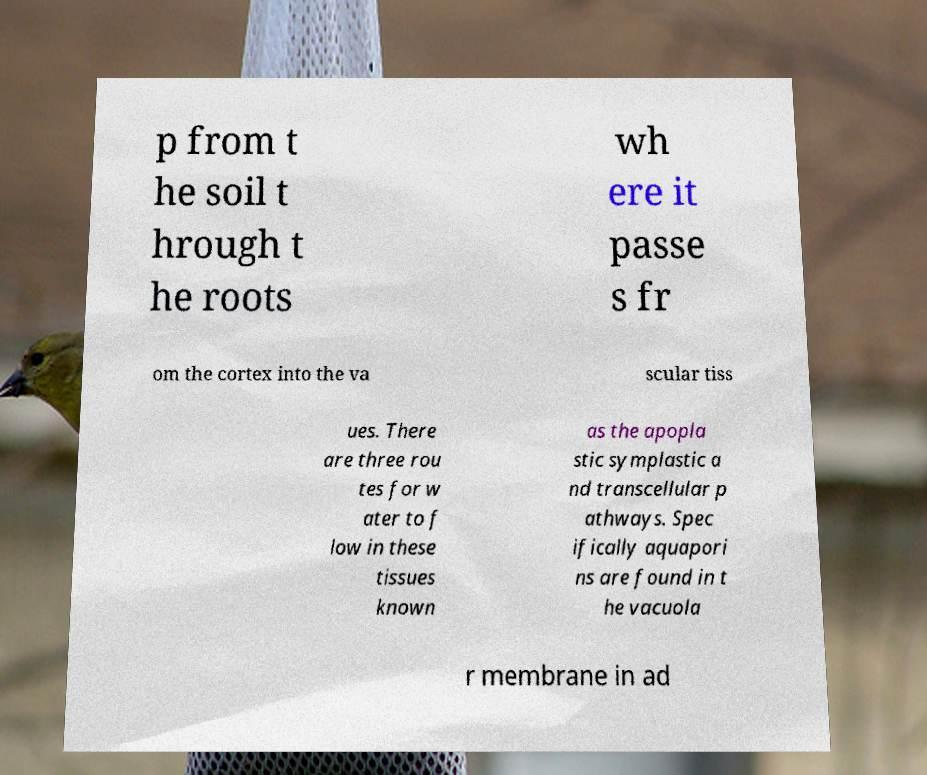For documentation purposes, I need the text within this image transcribed. Could you provide that? p from t he soil t hrough t he roots wh ere it passe s fr om the cortex into the va scular tiss ues. There are three rou tes for w ater to f low in these tissues known as the apopla stic symplastic a nd transcellular p athways. Spec ifically aquapori ns are found in t he vacuola r membrane in ad 